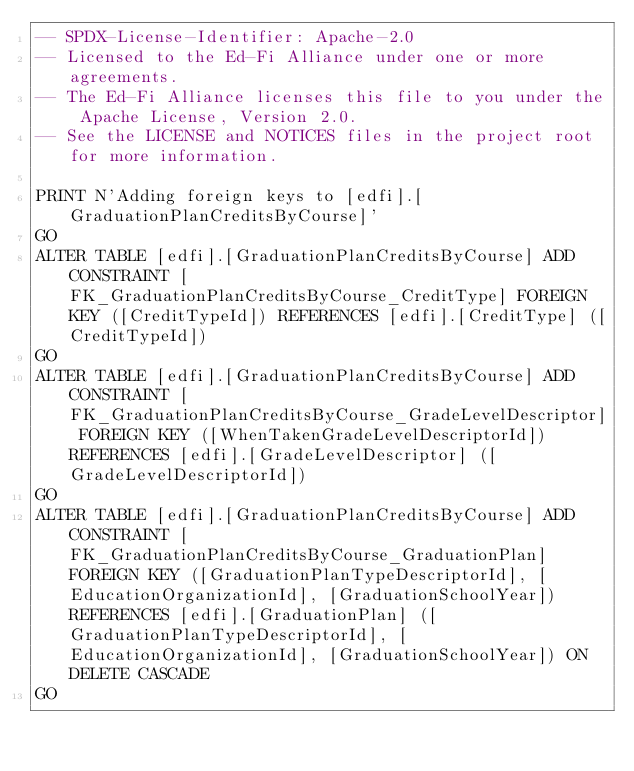<code> <loc_0><loc_0><loc_500><loc_500><_SQL_>-- SPDX-License-Identifier: Apache-2.0
-- Licensed to the Ed-Fi Alliance under one or more agreements.
-- The Ed-Fi Alliance licenses this file to you under the Apache License, Version 2.0.
-- See the LICENSE and NOTICES files in the project root for more information.

PRINT N'Adding foreign keys to [edfi].[GraduationPlanCreditsByCourse]'
GO
ALTER TABLE [edfi].[GraduationPlanCreditsByCourse] ADD CONSTRAINT [FK_GraduationPlanCreditsByCourse_CreditType] FOREIGN KEY ([CreditTypeId]) REFERENCES [edfi].[CreditType] ([CreditTypeId])
GO
ALTER TABLE [edfi].[GraduationPlanCreditsByCourse] ADD CONSTRAINT [FK_GraduationPlanCreditsByCourse_GradeLevelDescriptor] FOREIGN KEY ([WhenTakenGradeLevelDescriptorId]) REFERENCES [edfi].[GradeLevelDescriptor] ([GradeLevelDescriptorId])
GO
ALTER TABLE [edfi].[GraduationPlanCreditsByCourse] ADD CONSTRAINT [FK_GraduationPlanCreditsByCourse_GraduationPlan] FOREIGN KEY ([GraduationPlanTypeDescriptorId], [EducationOrganizationId], [GraduationSchoolYear]) REFERENCES [edfi].[GraduationPlan] ([GraduationPlanTypeDescriptorId], [EducationOrganizationId], [GraduationSchoolYear]) ON DELETE CASCADE
GO
</code> 